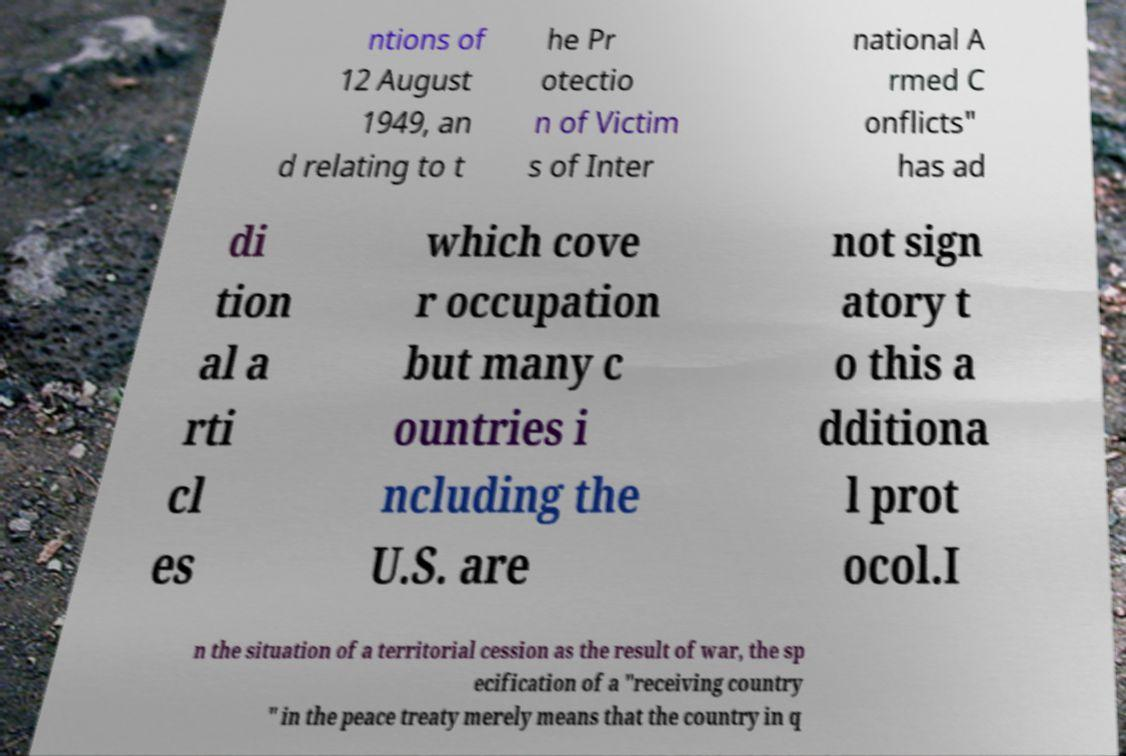There's text embedded in this image that I need extracted. Can you transcribe it verbatim? ntions of 12 August 1949, an d relating to t he Pr otectio n of Victim s of Inter national A rmed C onflicts" has ad di tion al a rti cl es which cove r occupation but many c ountries i ncluding the U.S. are not sign atory t o this a dditiona l prot ocol.I n the situation of a territorial cession as the result of war, the sp ecification of a "receiving country " in the peace treaty merely means that the country in q 